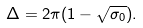Convert formula to latex. <formula><loc_0><loc_0><loc_500><loc_500>\Delta = 2 \pi ( 1 - \sqrt { \sigma _ { 0 } } ) .</formula> 